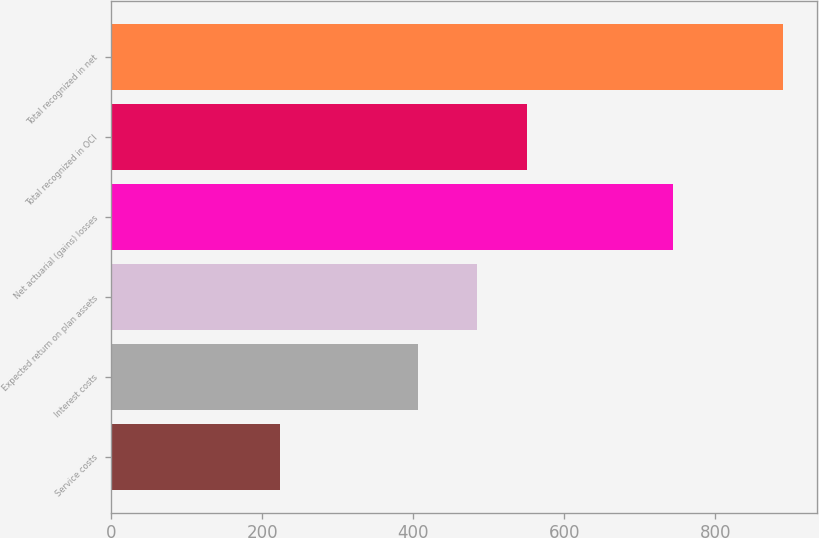Convert chart to OTSL. <chart><loc_0><loc_0><loc_500><loc_500><bar_chart><fcel>Service costs<fcel>Interest costs<fcel>Expected return on plan assets<fcel>Net actuarial (gains) losses<fcel>Total recognized in OCI<fcel>Total recognized in net<nl><fcel>224<fcel>406<fcel>484<fcel>744<fcel>550.6<fcel>890<nl></chart> 